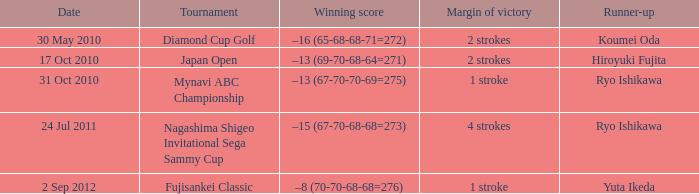Who was the Japan open runner up? Hiroyuki Fujita. 